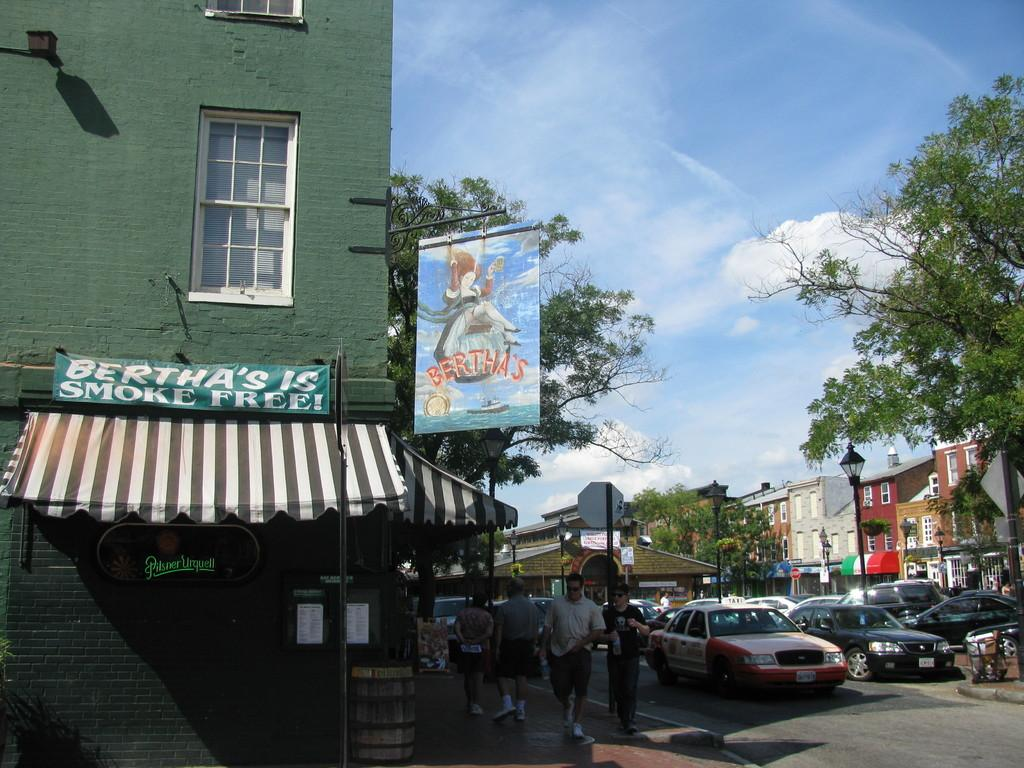<image>
Relay a brief, clear account of the picture shown. Two signs for Bertha's are posted outside the green building located on a street corner. 